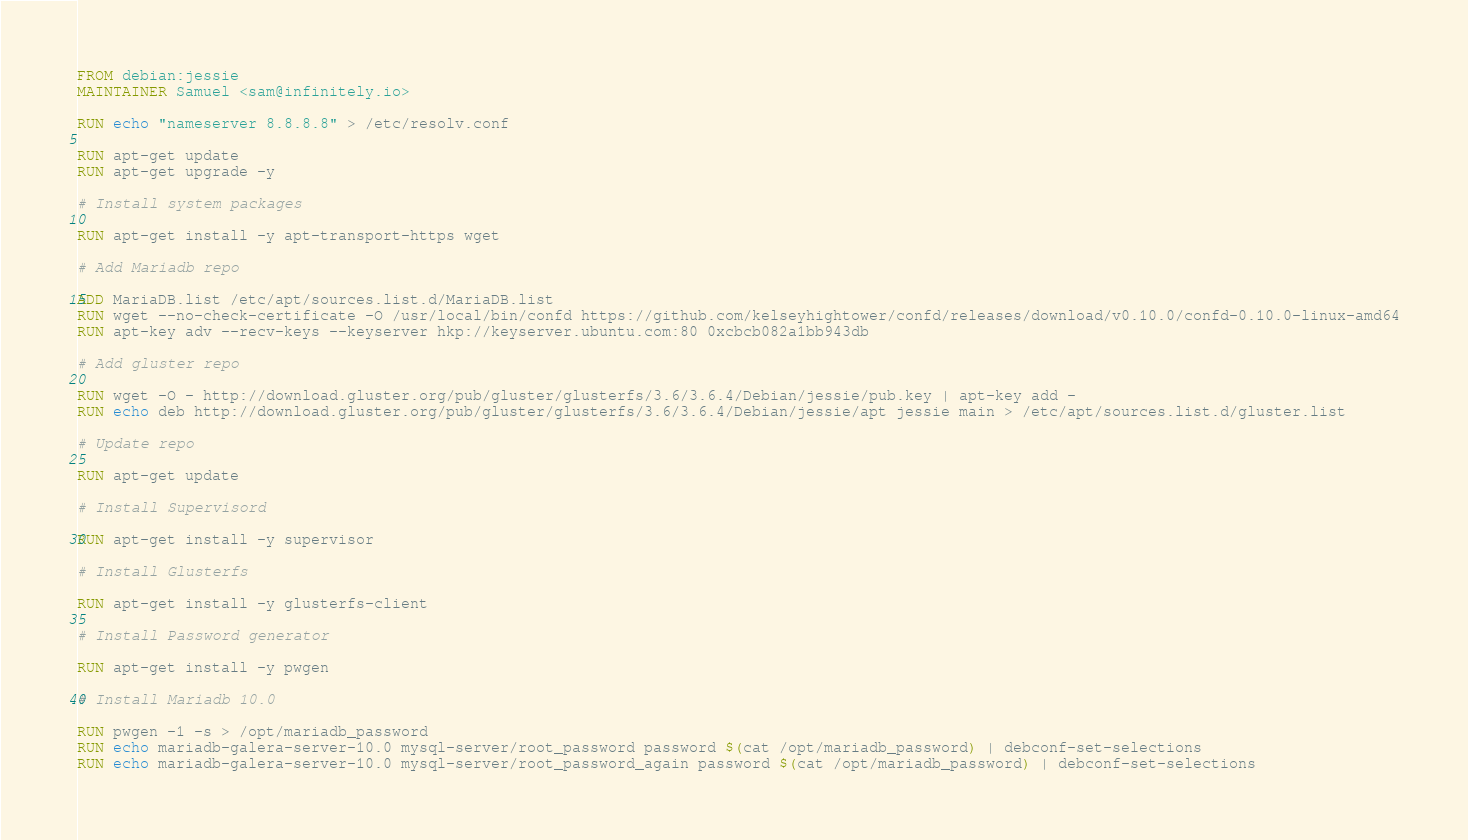Convert code to text. <code><loc_0><loc_0><loc_500><loc_500><_Dockerfile_>FROM debian:jessie
MAINTAINER Samuel <sam@infinitely.io>

RUN echo "nameserver 8.8.8.8" > /etc/resolv.conf

RUN apt-get update
RUN apt-get upgrade -y

# Install system packages

RUN apt-get install -y apt-transport-https wget

# Add Mariadb repo

ADD MariaDB.list /etc/apt/sources.list.d/MariaDB.list
RUN wget --no-check-certificate -O /usr/local/bin/confd https://github.com/kelseyhightower/confd/releases/download/v0.10.0/confd-0.10.0-linux-amd64
RUN apt-key adv --recv-keys --keyserver hkp://keyserver.ubuntu.com:80 0xcbcb082a1bb943db

# Add gluster repo

RUN wget -O - http://download.gluster.org/pub/gluster/glusterfs/3.6/3.6.4/Debian/jessie/pub.key | apt-key add -
RUN echo deb http://download.gluster.org/pub/gluster/glusterfs/3.6/3.6.4/Debian/jessie/apt jessie main > /etc/apt/sources.list.d/gluster.list

# Update repo

RUN apt-get update

# Install Supervisord

RUN apt-get install -y supervisor

# Install Glusterfs

RUN apt-get install -y glusterfs-client

# Install Password generator

RUN apt-get install -y pwgen

# Install Mariadb 10.0

RUN pwgen -1 -s > /opt/mariadb_password
RUN echo mariadb-galera-server-10.0 mysql-server/root_password password $(cat /opt/mariadb_password) | debconf-set-selections
RUN echo mariadb-galera-server-10.0 mysql-server/root_password_again password $(cat /opt/mariadb_password) | debconf-set-selections</code> 